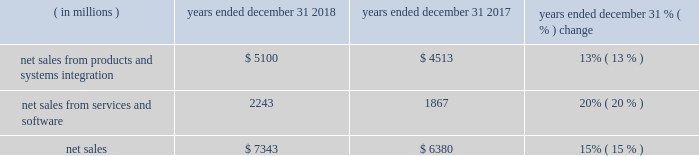Results of operations 20142018 compared to 2017 net sales .
The products and systems integration segment 2019s net sales represented 69% ( 69 % ) of our consolidated net sales in 2018 , compared to 71% ( 71 % ) in 2017 .
The services and software segment 2019s net sales represented 31% ( 31 % ) of our consolidated net sales in 2018 , compared to 29% ( 29 % ) in 2017 .
Net sales were up $ 963 million , or 15% ( 15 % ) , compared to 2017 .
The increase in net sales was driven by the americas and emea with a 13% ( 13 % ) increase in the products and systems integration segment and a 20% ( 20 % ) increase in the services and software segment .
This growth includes : 2022 $ 507 million of incremental revenue from the acquisitions of avigilon and plant in 2018 and kodiak networks and interexport which were acquired during 2017 ; 2022 $ 83 million from the adoption of accounting standards codification ( "asc" ) 606 ( see note 1 of our consolidated financial statements ) ; and 2022 $ 32 million from favorable currency rates .
Regional results include : 2022 the americas grew 17% ( 17 % ) across all products within both the products and systems integration and the services and software segments , inclusive of incremental revenue from acquisitions ; 2022 emea grew 18% ( 18 % ) on broad-based growth within all offerings within our products and systems integration and services and software segments , inclusive of incremental revenue from acquisitions ; and 2022 ap was relatively flat with growth in the services and software segment offset by lower products and systems integration revenue .
Products and systems integration the 13% ( 13 % ) growth in the products and systems integration segment was driven by the following : 2022 $ 318 million of incremental revenue from the acquisitions of avigilon in 2018 and interexport during 2017 ; 2022 $ 78 million from the adoption of asc 606 ; 2022 devices revenues were up significantly due to the acquisition of avigilon along with strong demand in the americas and emea ; and 2022 systems and systems integration revenues increased 10% ( 10 % ) in 2018 , as compared to 2017 driven by incremental revenue from avigilon , as well as system deployments in emea and ap .
Services and software the 20% ( 20 % ) growth in the services and software segment was driven by the following : 2022 $ 189 million of incremental revenue primarily from the acquisitions of plant and avigilon in 2018 and kodiak networks and interexport during 2017 ; 2022 $ 5 million from the adoption of asc 606 ; 2022 services were up $ 174 million , or 9% ( 9 % ) , driven by growth in both maintenance and managed service revenues , and incremental revenue from the acquisitions of interexport and plant ; and 2022 software was up $ 202 million , or 89% ( 89 % ) , driven primarily by incremental revenue from the acquisitions of plant , avigilon , and kodiak networks , and growth in our command center software suite. .
What was the percentage of the net sales from services and software in 2017? 
Computations: (1867 / 1867)
Answer: 1.0. 